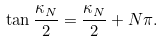Convert formula to latex. <formula><loc_0><loc_0><loc_500><loc_500>\tan \frac { \kappa _ { N } } { 2 } = \frac { \kappa _ { N } } { 2 } + N \pi .</formula> 